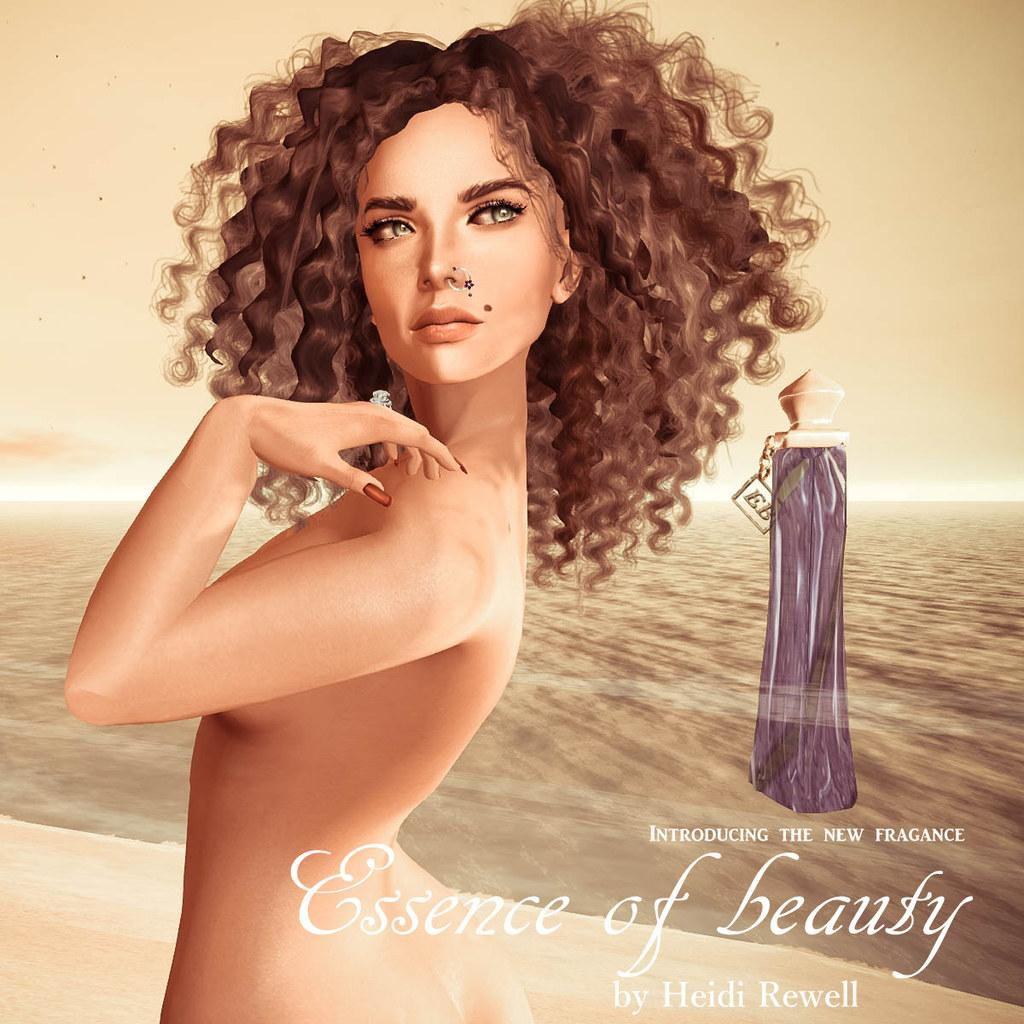<image>
Offer a succinct explanation of the picture presented. A perfume advertisement for the essence of beauty. 